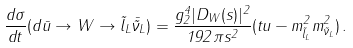<formula> <loc_0><loc_0><loc_500><loc_500>\frac { d \sigma } { d t } ( d \bar { u } \rightarrow W \rightarrow \tilde { l } _ { L } \bar { \tilde { \nu } } _ { L } ) = \frac { g ^ { 4 } _ { 2 } | D _ { W } ( s ) | ^ { 2 } } { 1 9 2 \pi s ^ { 2 } } ( t u - m ^ { 2 } _ { \tilde { l } _ { L } } m ^ { 2 } _ { \tilde { \nu } _ { L } } ) \, .</formula> 